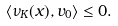Convert formula to latex. <formula><loc_0><loc_0><loc_500><loc_500>\langle \nu _ { K } ( x ) , v _ { 0 } \rangle \leq 0 .</formula> 